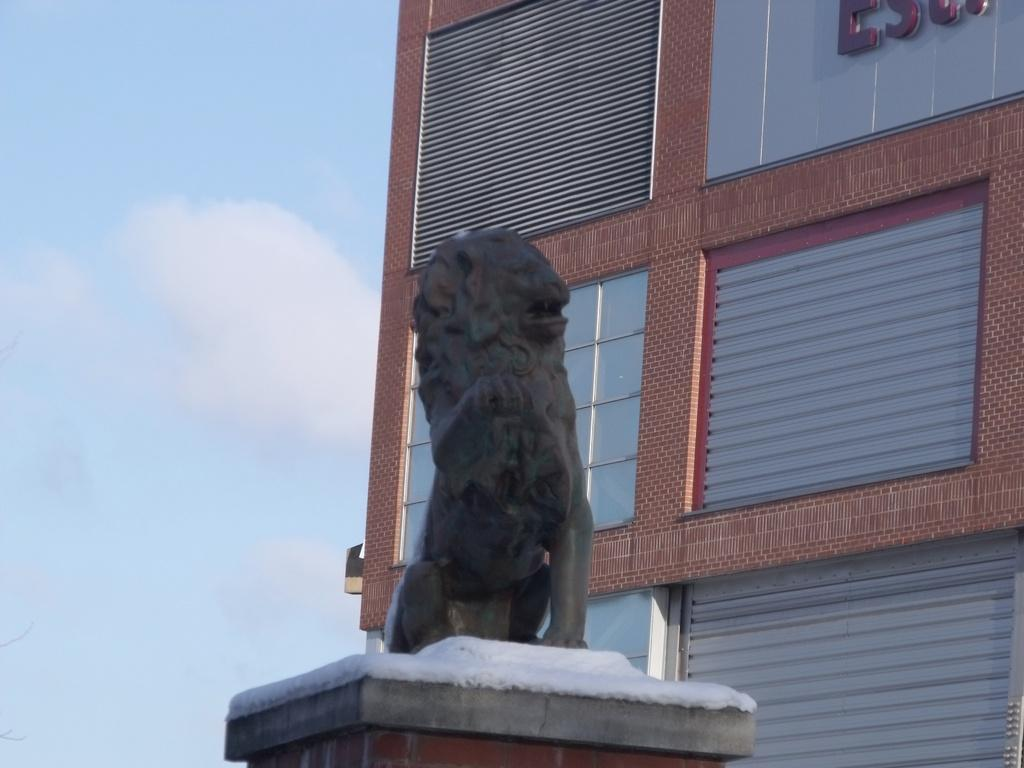What is the main subject in the center of the image? There is a statue in the center of the image. What is the statue standing on? The statue is on a solid structure. What can be seen in the background of the image? There is a sky, clouds, and a building visible in the background of the image. How many bits of wealth can be seen in the image? There is no wealth or bits present in the image. Is there an airplane flying in the background of the image? There is no airplane visible in the image; only the statue, solid structure, sky, clouds, and building are present. 